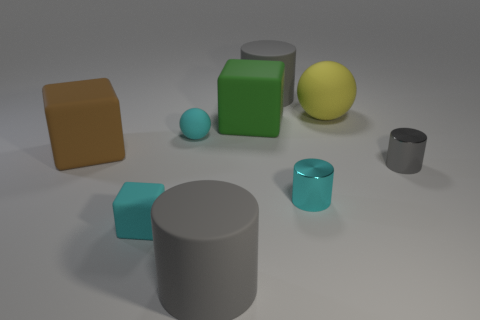Subtract all large cubes. How many cubes are left? 1 Subtract all brown cubes. How many gray cylinders are left? 3 Add 1 small gray metallic objects. How many objects exist? 10 Subtract all green cubes. How many cubes are left? 2 Subtract all cylinders. How many objects are left? 5 Subtract 1 spheres. How many spheres are left? 1 Subtract all brown cylinders. Subtract all yellow spheres. How many cylinders are left? 4 Subtract 0 blue balls. How many objects are left? 9 Subtract all tiny brown cylinders. Subtract all big matte blocks. How many objects are left? 7 Add 4 gray matte cylinders. How many gray matte cylinders are left? 6 